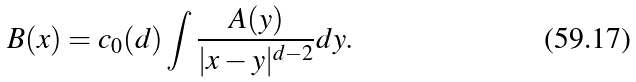<formula> <loc_0><loc_0><loc_500><loc_500>B ( x ) = c _ { 0 } ( d ) \int \frac { A ( y ) } { | x - y | ^ { d - 2 } } d y .</formula> 